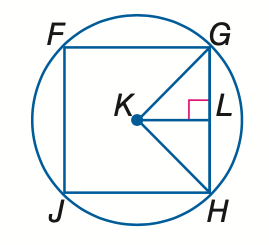Question: Square F G H J is inscribed in \odot K. Find the measure of a central angle.
Choices:
A. 45
B. 60
C. 90
D. 180
Answer with the letter. Answer: C 